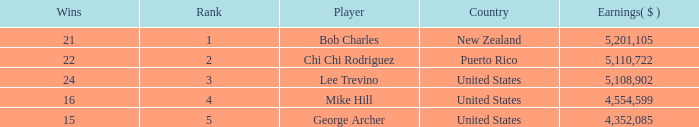What is the lowest level of Earnings($) to have a Wins value of 22 and a Rank lower than 2? None. 